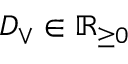Convert formula to latex. <formula><loc_0><loc_0><loc_500><loc_500>D _ { \vee } \in \mathbb { R } _ { \geq 0 }</formula> 